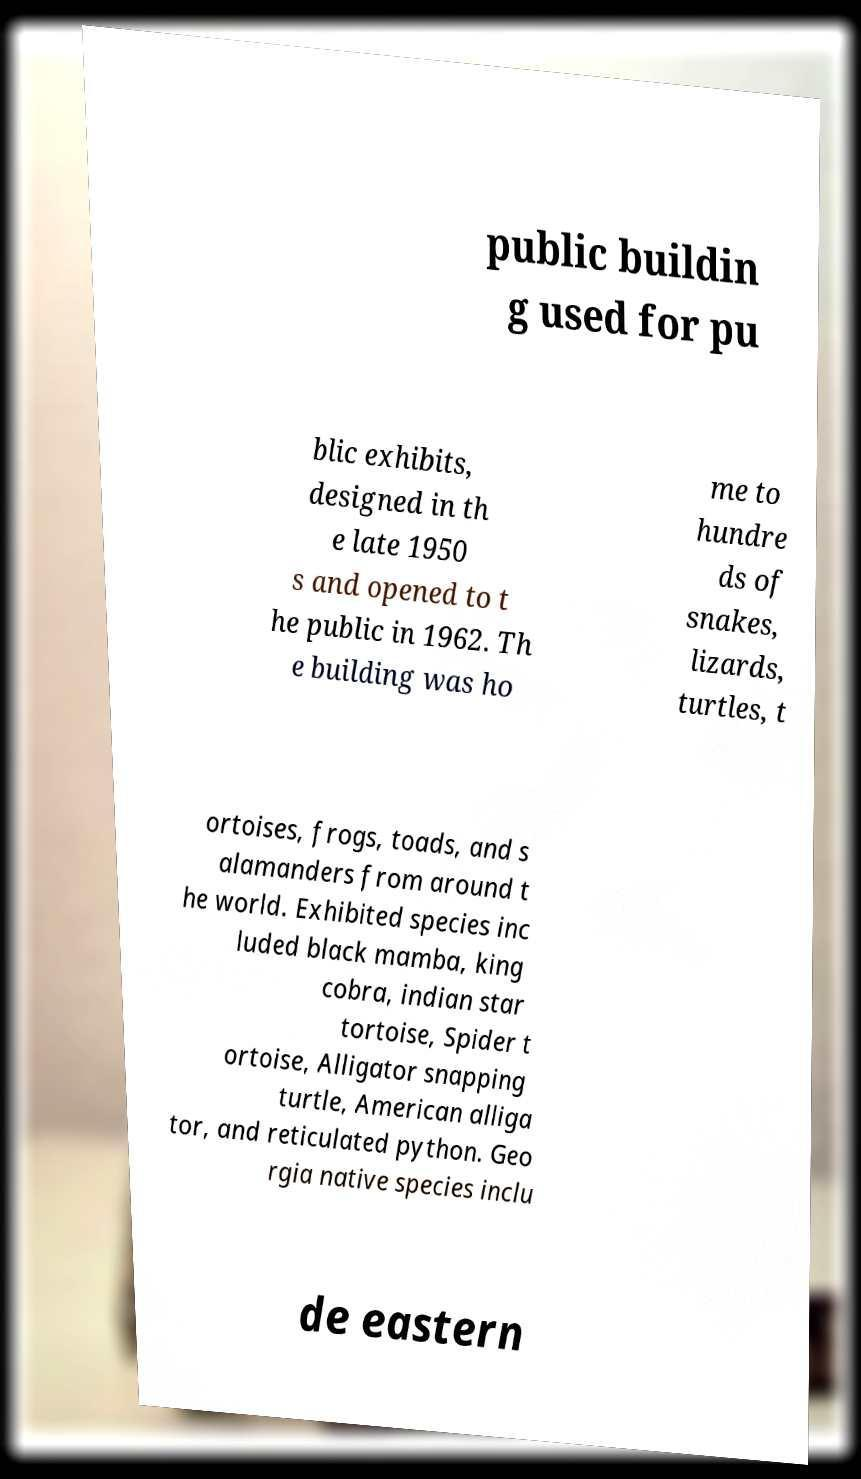Could you extract and type out the text from this image? public buildin g used for pu blic exhibits, designed in th e late 1950 s and opened to t he public in 1962. Th e building was ho me to hundre ds of snakes, lizards, turtles, t ortoises, frogs, toads, and s alamanders from around t he world. Exhibited species inc luded black mamba, king cobra, indian star tortoise, Spider t ortoise, Alligator snapping turtle, American alliga tor, and reticulated python. Geo rgia native species inclu de eastern 